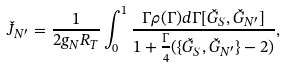Convert formula to latex. <formula><loc_0><loc_0><loc_500><loc_500>\check { J } _ { N ^ { \prime } } = \frac { 1 } { 2 g _ { N } R _ { T } } \int _ { 0 } ^ { 1 } \frac { \Gamma \rho ( \Gamma ) d \Gamma [ \check { G } _ { S } , \check { G } _ { N ^ { \prime } } ] } { 1 + \frac { \Gamma } { 4 } ( \{ \check { G } _ { S } , \check { G } _ { N ^ { \prime } } \} - 2 ) } ,</formula> 